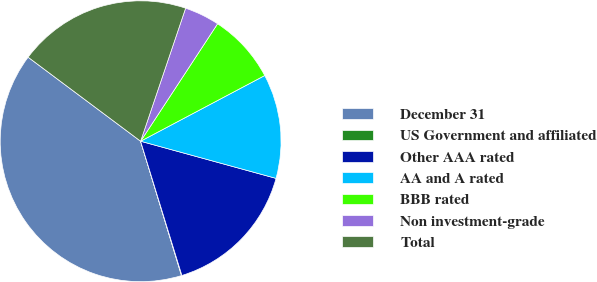Convert chart. <chart><loc_0><loc_0><loc_500><loc_500><pie_chart><fcel>December 31<fcel>US Government and affiliated<fcel>Other AAA rated<fcel>AA and A rated<fcel>BBB rated<fcel>Non investment-grade<fcel>Total<nl><fcel>39.91%<fcel>0.05%<fcel>15.99%<fcel>12.01%<fcel>8.02%<fcel>4.04%<fcel>19.98%<nl></chart> 